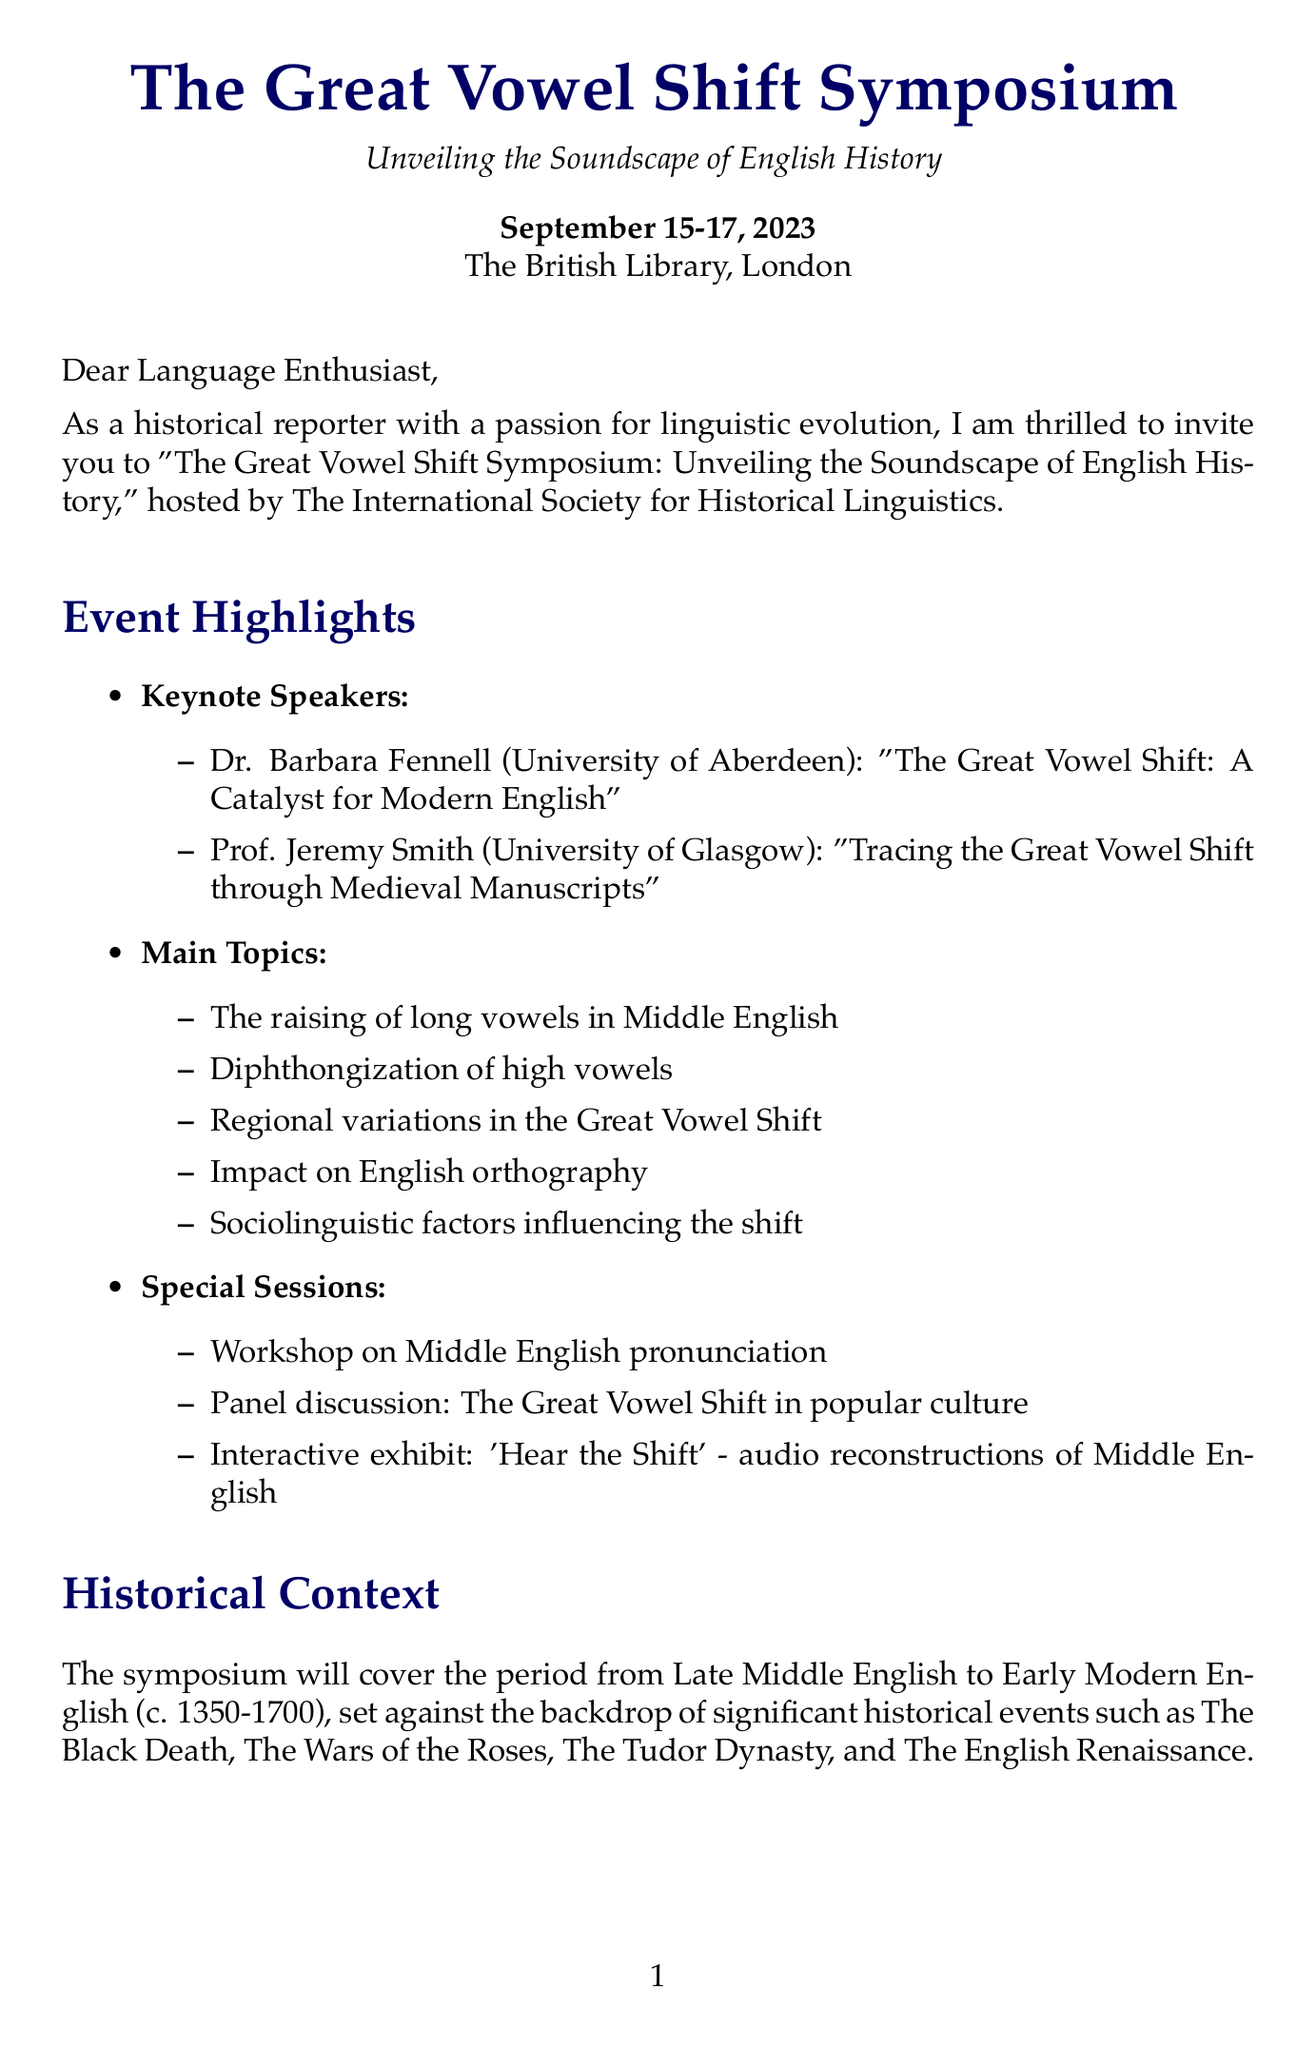What are the dates of the symposium? The symposium will take place from September 15 to 17, 2023.
Answer: September 15-17, 2023 Who is one of the keynote speakers? The document mentions two keynote speakers; one of them is Dr. Barbara Fennell.
Answer: Dr. Barbara Fennell What is the early bird registration fee? The document specifies the early bird fee for registration as £250.
Answer: £250 Which historical event is covered in the context of the symposium? One significant event mentioned is The Black Death.
Answer: The Black Death What is one example of a key sound change? The document lists several sound changes; one example is the change from Middle English /iː/ to Modern English /aɪ/.
Answer: Middle English /iː/ to Modern English /aɪ/ What type of sessions are included in the symposium? The document outlines special sessions including workshops and panels, specifying a workshop on Middle English pronunciation as one of them.
Answer: Workshop on Middle English pronunciation What is the contact email for the symposium? The document provides a specific email address for inquiries, which is gvs.symposium@historicallinguistics.org.
Answer: gvs.symposium@historicallinguistics.org What organization is hosting the symposium? The host organization mentioned in the document is The International Society for Historical Linguistics.
Answer: The International Society for Historical Linguistics 